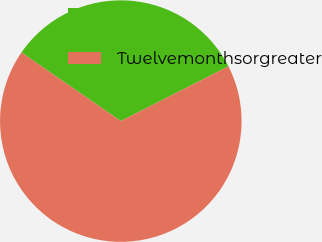Convert chart. <chart><loc_0><loc_0><loc_500><loc_500><pie_chart><ecel><fcel>Twelvemonthsorgreater<nl><fcel>32.9%<fcel>67.1%<nl></chart> 